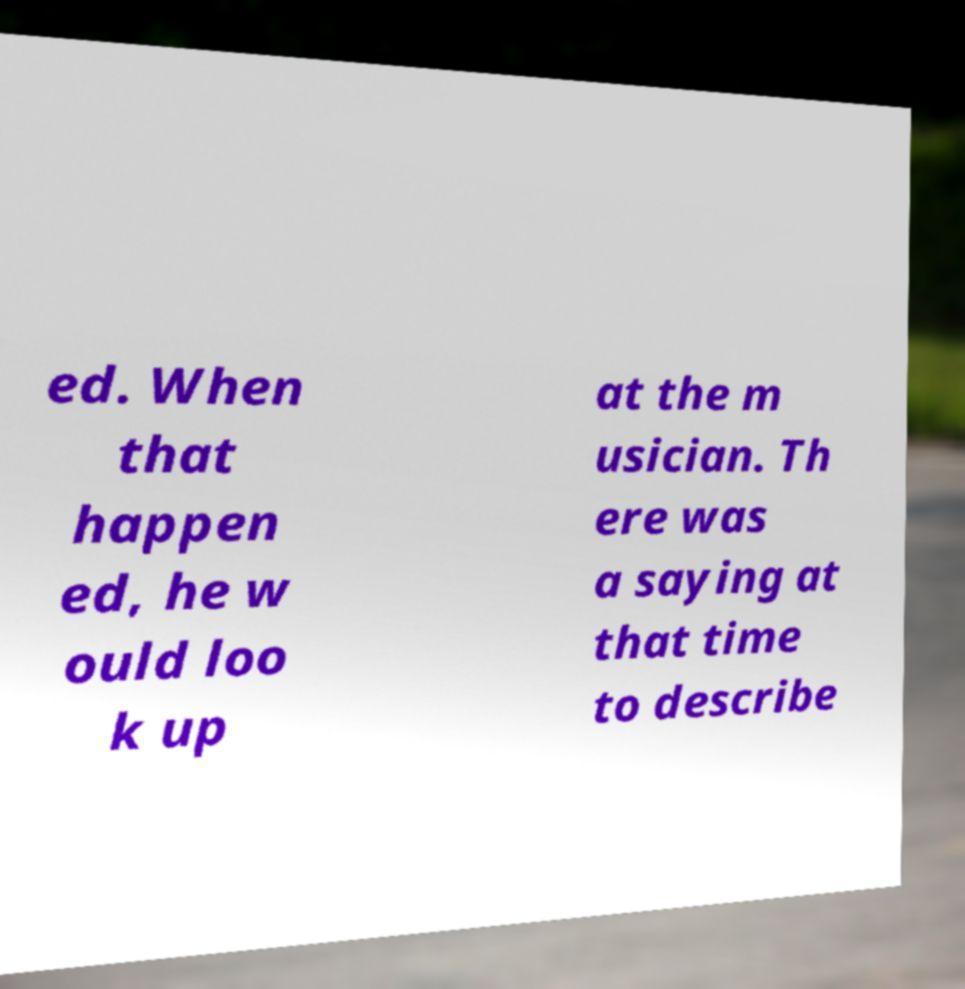Can you read and provide the text displayed in the image?This photo seems to have some interesting text. Can you extract and type it out for me? ed. When that happen ed, he w ould loo k up at the m usician. Th ere was a saying at that time to describe 